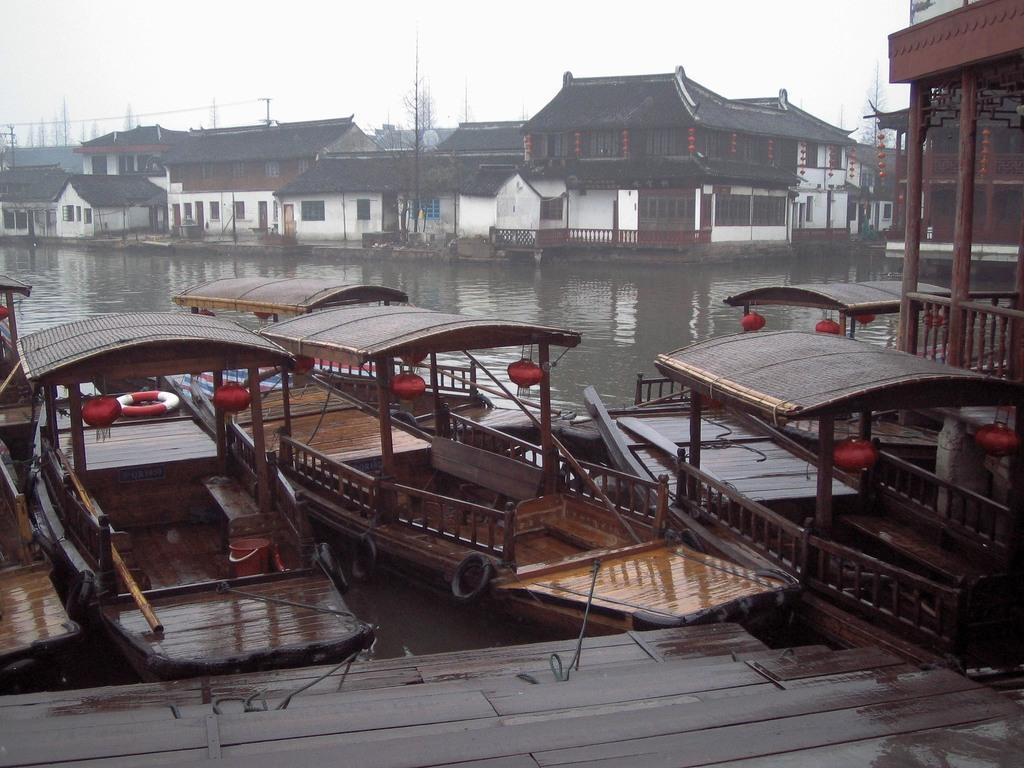How would you summarize this image in a sentence or two? In this image at the bottom there is a river and in the foreground there are some boats and a wooden bridge, and in the background there are some houses. On the top of the image there is sky, and in the background there are some trees and poles. 